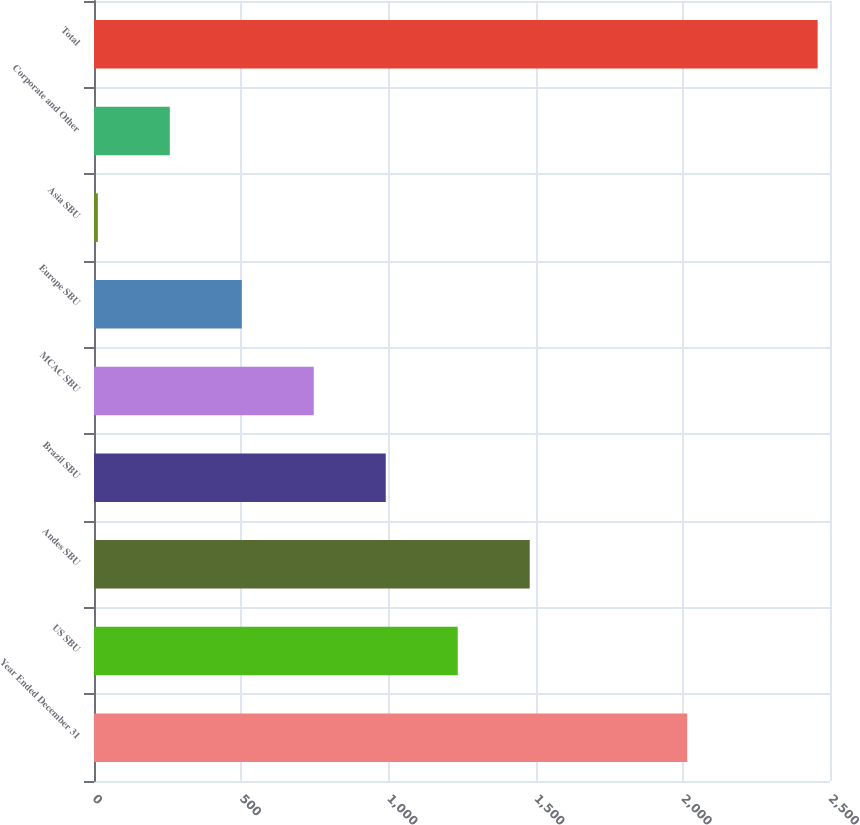Convert chart to OTSL. <chart><loc_0><loc_0><loc_500><loc_500><bar_chart><fcel>Year Ended December 31<fcel>US SBU<fcel>Andes SBU<fcel>Brazil SBU<fcel>MCAC SBU<fcel>Europe SBU<fcel>Asia SBU<fcel>Corporate and Other<fcel>Total<nl><fcel>2015<fcel>1235.5<fcel>1480<fcel>991<fcel>746.5<fcel>502<fcel>13<fcel>257.5<fcel>2458<nl></chart> 